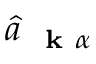<formula> <loc_0><loc_0><loc_500><loc_500>\hat { a } _ { k \alpha }</formula> 